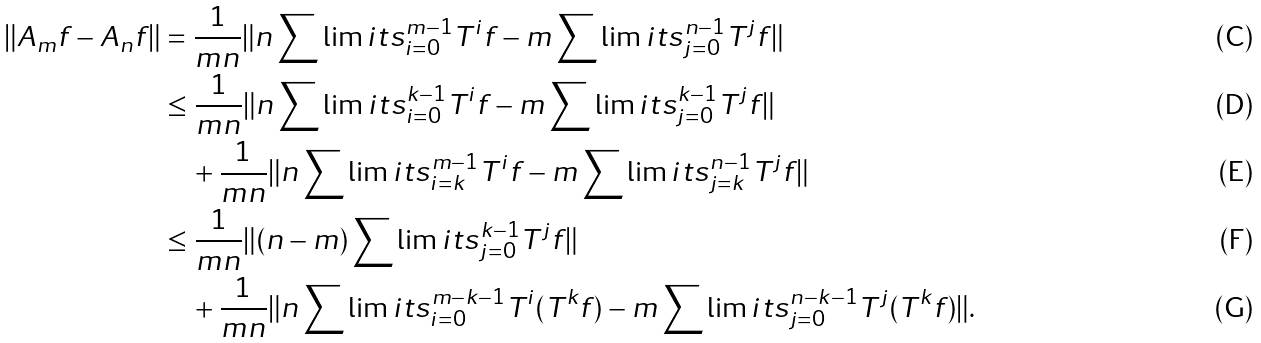<formula> <loc_0><loc_0><loc_500><loc_500>\| A _ { m } f - A _ { n } f \| & = \frac { 1 } { m n } \| n \sum \lim i t s ^ { m - 1 } _ { i = 0 } T ^ { i } f - m \sum \lim i t s ^ { n - 1 } _ { j = 0 } T ^ { j } f \| \\ & \leq \frac { 1 } { m n } \| n \sum \lim i t s ^ { k - 1 } _ { i = 0 } T ^ { i } f - m \sum \lim i t s ^ { k - 1 } _ { j = 0 } T ^ { j } f \| \\ & \quad + \frac { 1 } { m n } \| n \sum \lim i t s ^ { m - 1 } _ { i = k } T ^ { i } f - m \sum \lim i t s ^ { n - 1 } _ { j = k } T ^ { j } f \| \\ & \leq \frac { 1 } { m n } \| ( n - m ) \sum \lim i t s ^ { k - 1 } _ { j = 0 } T ^ { j } f \| \\ & \quad + \frac { 1 } { m n } \| n \sum \lim i t s ^ { m - k - 1 } _ { i = 0 } T ^ { i } ( T ^ { k } f ) - m \sum \lim i t s ^ { n - k - 1 } _ { j = 0 } T ^ { j } ( T ^ { k } f ) \| .</formula> 